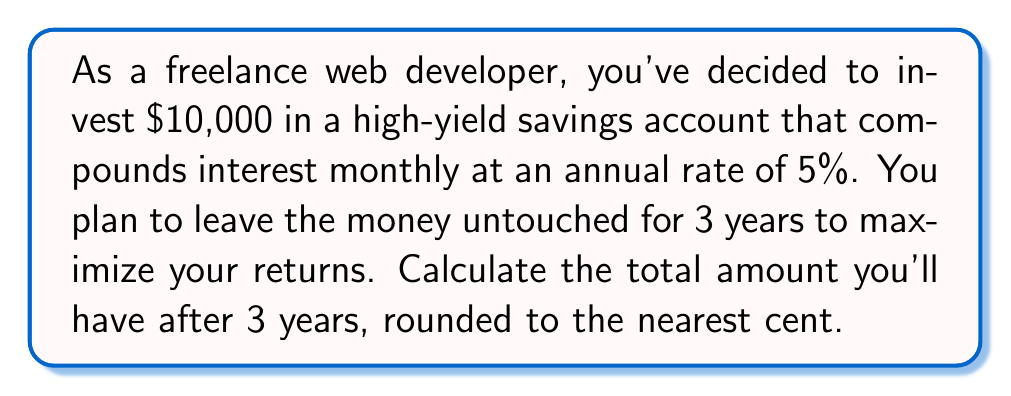Could you help me with this problem? To solve this problem, we'll use the compound interest formula:

$$A = P(1 + \frac{r}{n})^{nt}$$

Where:
$A$ = Final amount
$P$ = Principal (initial investment)
$r$ = Annual interest rate (as a decimal)
$n$ = Number of times interest is compounded per year
$t$ = Number of years

Given:
$P = \$10,000$
$r = 0.05$ (5% as a decimal)
$n = 12$ (compounded monthly)
$t = 3$ years

Step 1: Plug the values into the formula
$$A = 10000(1 + \frac{0.05}{12})^{12 \cdot 3}$$

Step 2: Simplify the expression inside the parentheses
$$A = 10000(1 + 0.004167)^{36}$$

Step 3: Calculate the power
$$A = 10000(1.004167)^{36}$$

Step 4: Use a calculator to compute the final result
$$A = 10000 \cdot 1.161616$$
$$A = 11616.16$$

Step 5: Round to the nearest cent
$$A = \$11,616.16$$
Answer: $11,616.16 